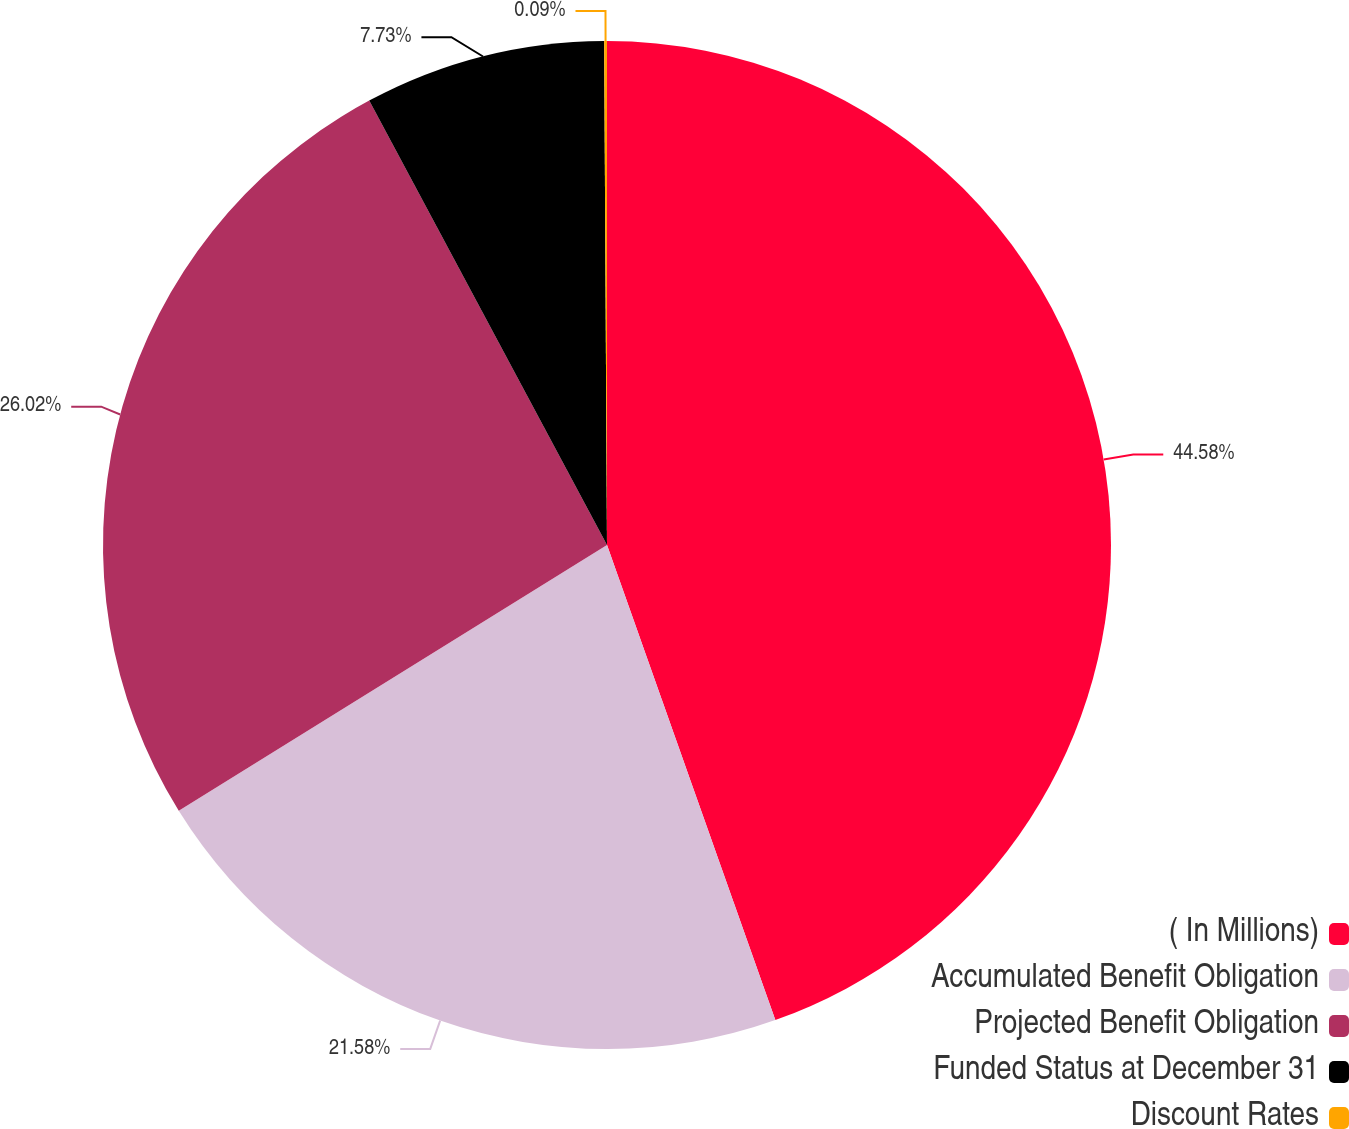Convert chart to OTSL. <chart><loc_0><loc_0><loc_500><loc_500><pie_chart><fcel>( In Millions)<fcel>Accumulated Benefit Obligation<fcel>Projected Benefit Obligation<fcel>Funded Status at December 31<fcel>Discount Rates<nl><fcel>44.58%<fcel>21.58%<fcel>26.02%<fcel>7.73%<fcel>0.09%<nl></chart> 